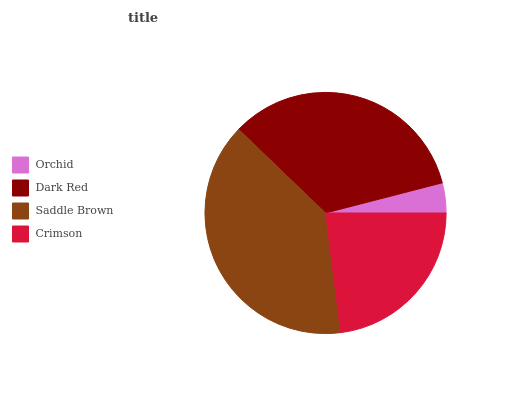Is Orchid the minimum?
Answer yes or no. Yes. Is Saddle Brown the maximum?
Answer yes or no. Yes. Is Dark Red the minimum?
Answer yes or no. No. Is Dark Red the maximum?
Answer yes or no. No. Is Dark Red greater than Orchid?
Answer yes or no. Yes. Is Orchid less than Dark Red?
Answer yes or no. Yes. Is Orchid greater than Dark Red?
Answer yes or no. No. Is Dark Red less than Orchid?
Answer yes or no. No. Is Dark Red the high median?
Answer yes or no. Yes. Is Crimson the low median?
Answer yes or no. Yes. Is Orchid the high median?
Answer yes or no. No. Is Dark Red the low median?
Answer yes or no. No. 